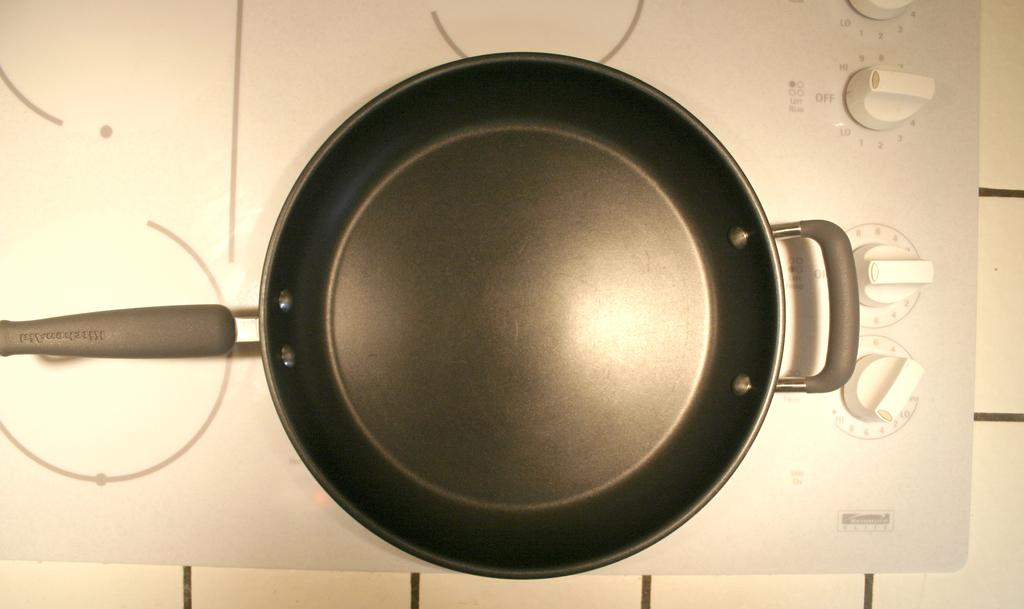What type of stove is shown in the image? There is an induction stove in the image. What other object can be seen in the image? There is a hand tool in the image. What is the third object visible in the image? There is a cement bowl in the image. How many women are swimming in the lake in the image? There is no lake or women present in the image. What type of carpenter is using the hand tool in the image? There is no carpenter or specific hand tool usage mentioned in the image. 